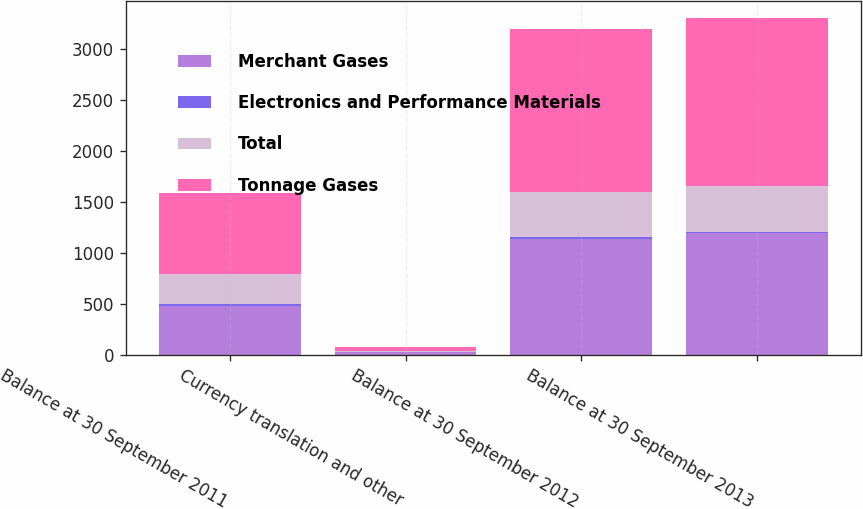Convert chart to OTSL. <chart><loc_0><loc_0><loc_500><loc_500><stacked_bar_chart><ecel><fcel>Balance at 30 September 2011<fcel>Currency translation and other<fcel>Balance at 30 September 2012<fcel>Balance at 30 September 2013<nl><fcel>Merchant Gases<fcel>479.2<fcel>29.4<fcel>1138.6<fcel>1192<nl><fcel>Electronics and Performance Materials<fcel>14.1<fcel>0.6<fcel>14.7<fcel>15.2<nl><fcel>Total<fcel>302.9<fcel>6.8<fcel>445.1<fcel>446.6<nl><fcel>Tonnage Gases<fcel>796.2<fcel>36.8<fcel>1598.4<fcel>1653.8<nl></chart> 